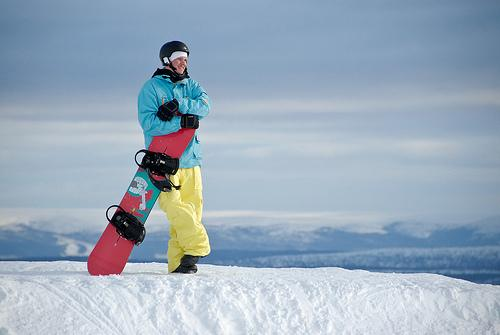What is the primary sentiment one could associate with this image? The sentiment could be excitement or adventure, as it shows a snowboarder in bright attire on top of a snow-covered mountain. Describe the geographical features seen in the image. There are high, snow-covered mountains with ski tracks, a mountain range in the distance, and cloudy skies in the background. How would you describe the scene and atmosphere of the image? It's a snowy mountain scene with a snowboarder dressed in bright clothing, creating a lively and adventurous atmosphere. Briefly describe the girl's outfit and what she is holding. The girl is wearing a white hat, a blue jacket, yellow snow pants, black gloves, and holding a pink snowboard. What is the color of the girl's jacket and what activity is she involved in? The girl's jacket is blue, and she is snowboarding or preparing to snowboard. Find and describe one unique detail about the girl's snowboard. The snowboard is bright pink and has two black feet rests. Identify three different items that the girl is wearing and their colors. White hat, blue jacket, and yellow snow pants. What can you say about the sky and mountains in the image? The sky appears cloudy, and there are high snow-covered mountains in the background. Assuming this is a competition, how many gear items is the girl wearing or holding that distinguishes her from other competitors? The girl has at least five distinguishing gear items: her white hat, blue jacket, yellow snow pants, black gloves, and pink snowboard. What are the most dominant colors and elements in the image? Dominant colors are white, blue, yellow, and pink, with elements like the girl, her snowboard, mountains, and clouds. What color are the gloves the snowboarder is wearing? Black Describe the scene in this image. A female snowboarder on top of a mountain, wearing snow gear and holding a pink snowboard, with a cloudy sky and mountain range in the background. Is the girl wearing a helmet with purple stripes? This is misleading because the girl is wearing a black helmet, not one with purple stripes. What activity is the person in this image participating in or preparing for? Snowboarding Mention the colors present on the snowboard.  Pink and red Is the snowboarder wearing a red jacket? This is misleading because the snowboarder is actually wearing a blue jacket, not a red one. What color is the sky in the image? Dark blue and white Is the person in the image a man or a woman? Woman What is the color of the girl's jacket? Blue Is there a large, brown cabin in the background? This is misleading because there is no mention of a cabin in the provided information about the image. Is the snowboarder wearing a helmet? If so, what color is it? Yes, black What type of jacket is the girl wearing? Blue ski jacket What type of landscape is depicted in the image? Snowy mountain Does the man have a long, bushy beard? This is misleading because there is no mention of a beard in any of the provided information about the man. What is the weather condition in the background of the image? Cloudy Are the mountains in the distance covered with green trees? This is misleading because the mountains are actually covered with snow, not green trees. What are the two types of mountain features depicted in the background? Mountain range and snowy mountain Is the person in the image on top of a mountain or at the bottom? Top of a mountain Is the girl's snowboard green with white stripes? This is misleading because the snowboard is actually pink, not green with white stripes. What color is the snowboard the girl is holding? Pink What is the gender of the person in the image? Female Identify the color and style of the girl's pants. Yellow snow pants Is the person in the image smiling? No Identify the colors on the snowboard. Red, pink, and teal What is the dominant color in the sky? Dark blue What type of object is the girl holding? A snowboard 